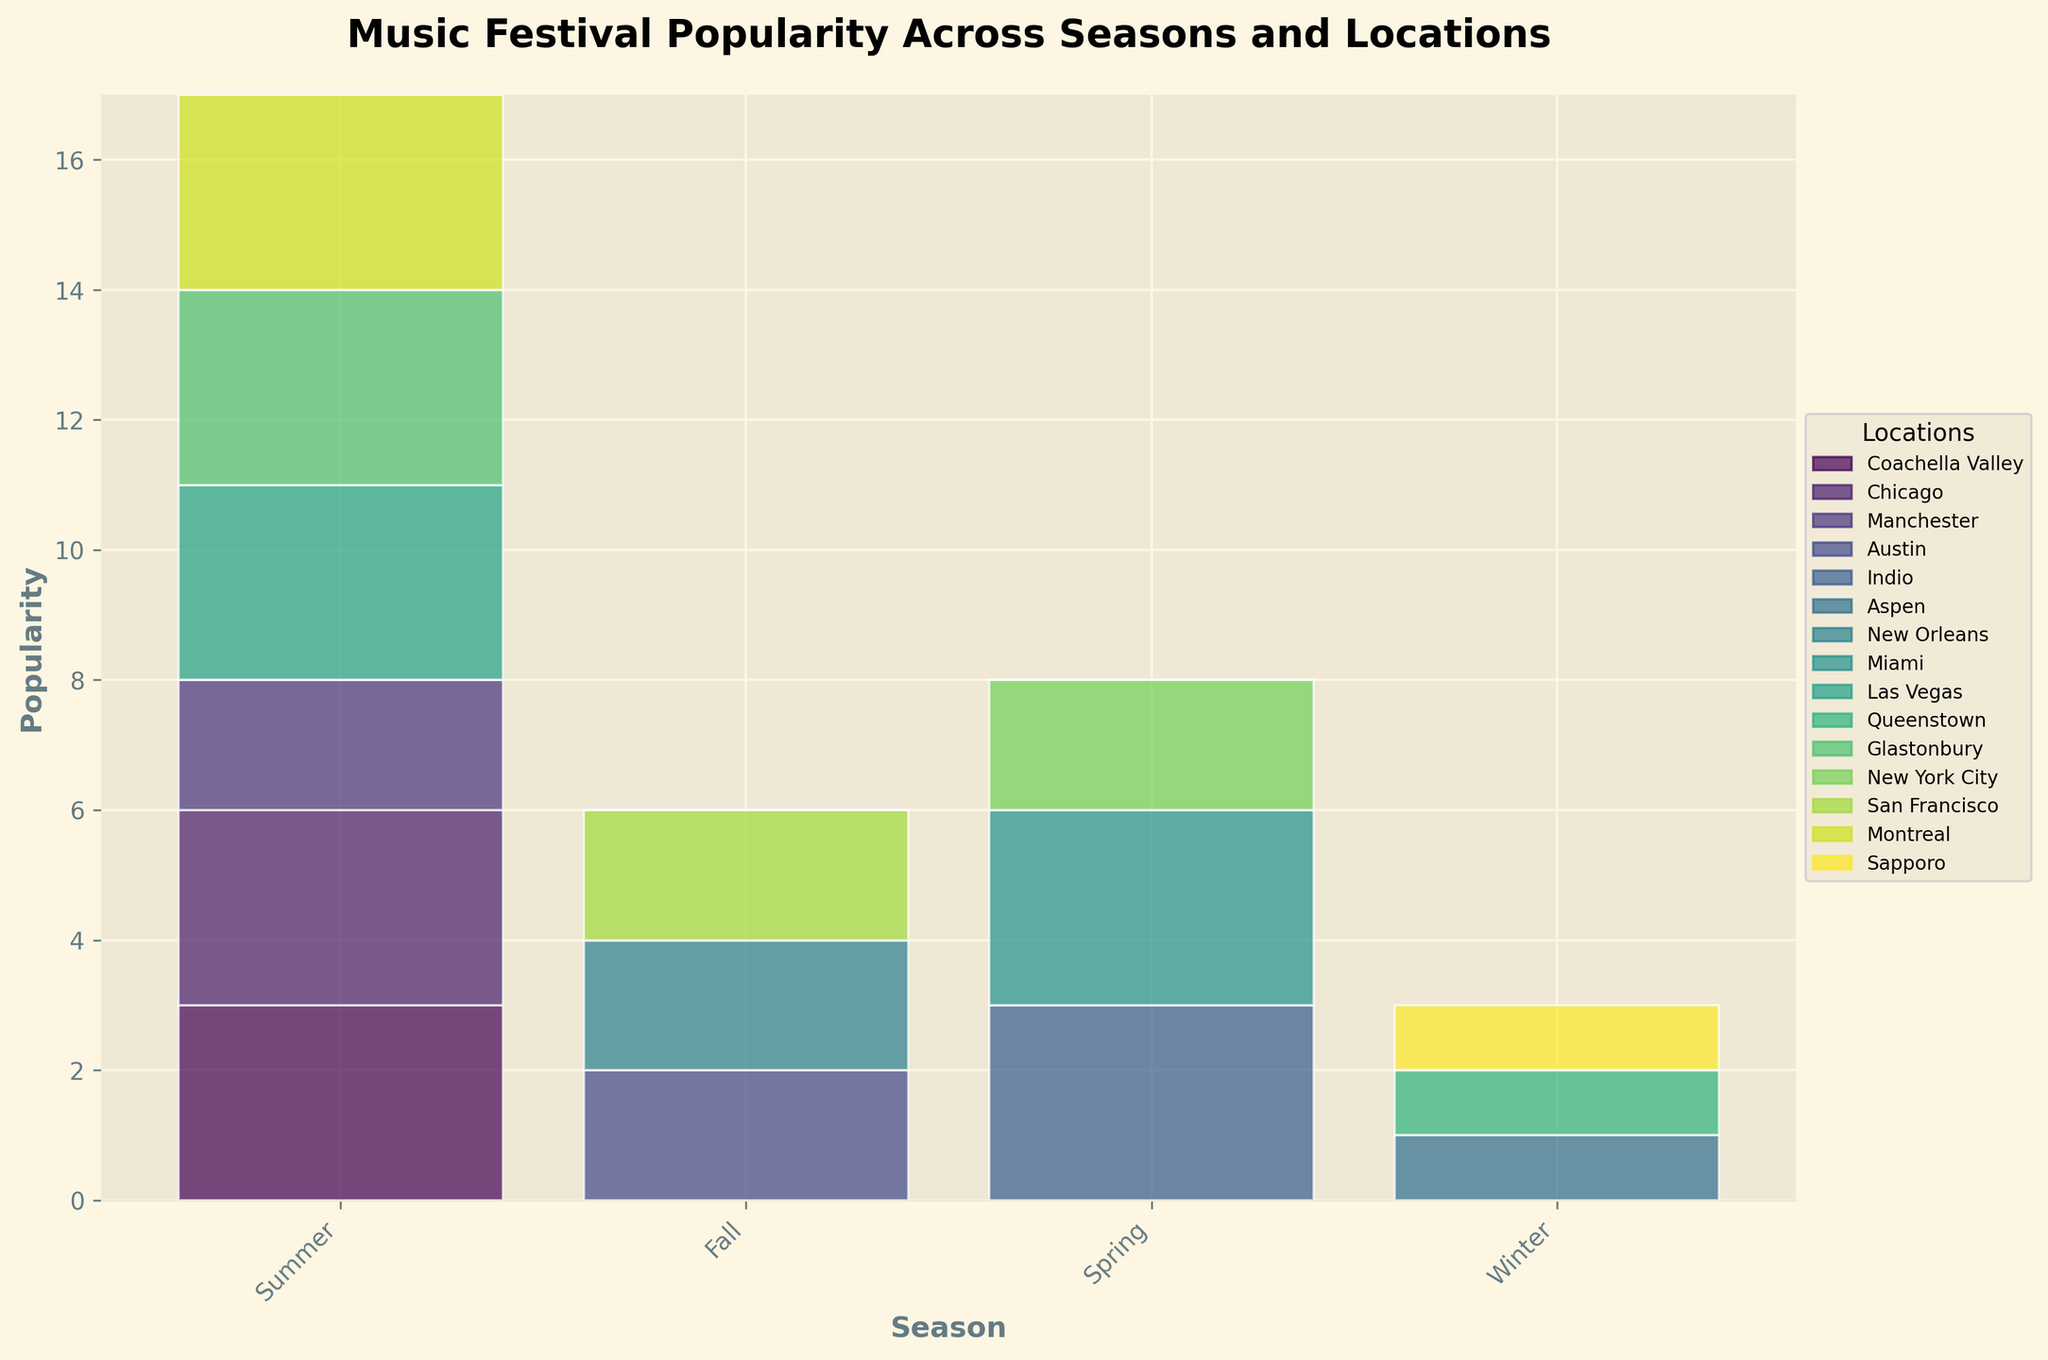Which season has the highest overall festival popularity? To determine which season has the highest overall festival popularity, sum the popularity values for each season by looking at the overall heights of bars for each season. Summer has the tallest bars overall across all festivals, indicating it has the highest overall popularity.
Answer: Summer How many locations host festivals in the winter season? To find the number of locations hosting festivals in the winter season, look at how many bars are stacked in the winter category on the horizontal axis. There are three different colors (representing different locations) stacked in the winter season.
Answer: Three Which location has the lowest festival popularity and in which season? To identify the location with the lowest festival popularity, look for the locations with the smallest bar segments and correlate them with their respective seasons. The smallest segments are in Winter for Aspen, Queenstown, and Sapporo, with the smallest popularity, likely for Sapporo given its smallest segment size.
Answer: Sapporo in Winter Between Spring and Fall, which season has higher average festival popularity? Calculate the average festival popularity for Spring and Fall by averaging the segment heights for each location within these seasons. Sum the segment heights first and then divide by the number of segments. After comparison, Spring shows higher average popularity due to more 'High' popularity segments compared to Fall.
Answer: Spring Does any season have a uniform festival popularity across all locations? To determine if any season has a uniform festival popularity across all locations, check if all the bars in a season are of the same height. For each season, all bars are of varying heights, indicating no uniformity in popularity across locations in any season.
Answer: No Which festival in the summer season has the highest popularity? Look at the individual bars within the Summer category and identify the tallest one, which corresponds to the highest popularity festival. The tallest bar within Summer is Coachella Valley, indicating Coachella festival.
Answer: Coachella How does the popularity of New York City's Governors Ball in Spring compare to Voodoo Music + Arts festival in Fall? Compare the segment heights for New York City in Spring (Governors Ball) with New Orleans in Fall (Voodoo Music + Arts). Both are medium popularity, hence they have equal heights.
Answer: Equal What is the total festival popularity for Las Vegas across all seasons? Sum the heights of bars corresponding to Las Vegas across all seasons. The Las Vegas festival occurs only in Summer with a 'High' popularity score. Thus, the total popularity is just the height of this single segment.
Answer: High Which season has the most varied festival popularity across locations? To find the season with the most varied festival popularity across locations, observe which season has the bars with the biggest differences in height between its locations. Summer shows a wide range: high for some (Coachella, Lollapalooza) and medium for others (Parklife), indicating it has the most varied popularity.
Answer: Summer What is the combined popularity score for Austin City Limits in Fall and Stagecoach in Spring? Sum the heights of the bars representing Austin in Fall (Austin City Limits) and Indio in Spring (Stagecoach). Both have Medium, thus summed result is Medium + Medium.
Answer: Medium + Medium 